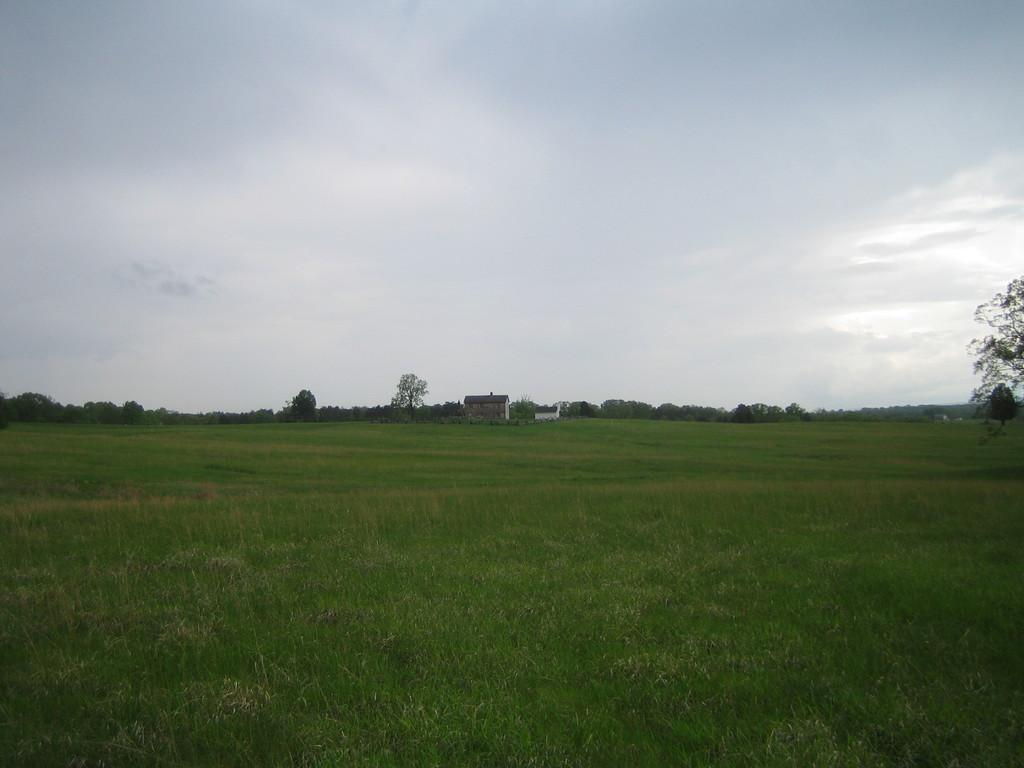What type of vegetation can be seen in the image? There is grass and trees in the image. What type of structure is present in the image? There is a house in the image. What can be seen in the background of the image? The sky is visible in the background of the image. What is the tendency of the grass to act in a certain way in the image? The grass in the image does not exhibit any specific tendency or action, as it is a static element in the image. 